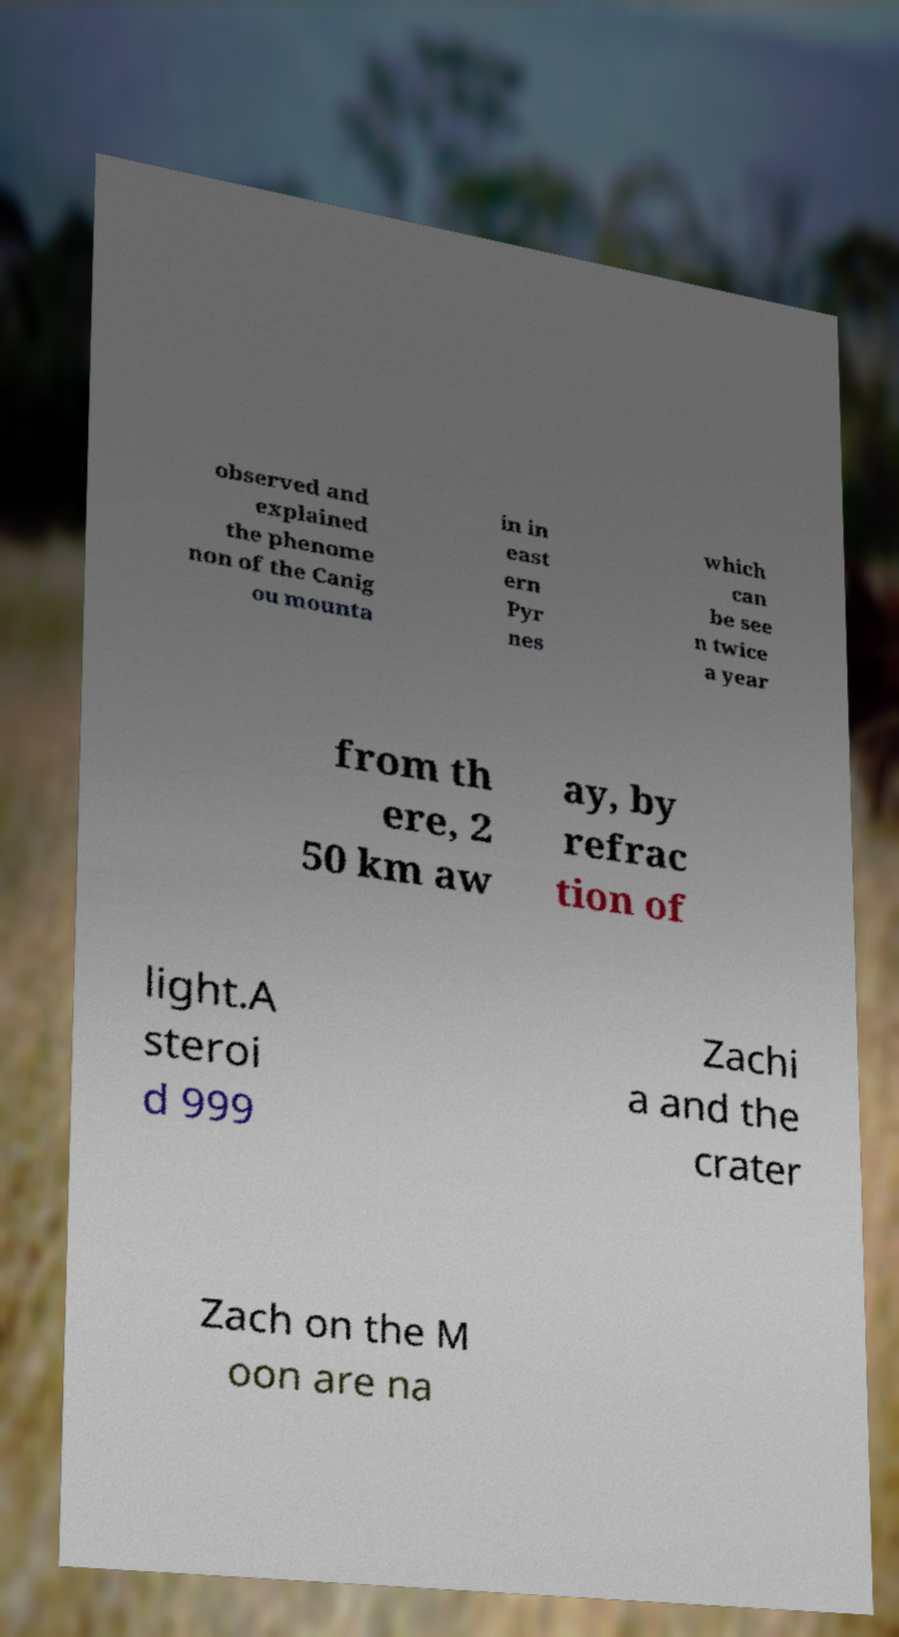Please identify and transcribe the text found in this image. observed and explained the phenome non of the Canig ou mounta in in east ern Pyr nes which can be see n twice a year from th ere, 2 50 km aw ay, by refrac tion of light.A steroi d 999 Zachi a and the crater Zach on the M oon are na 